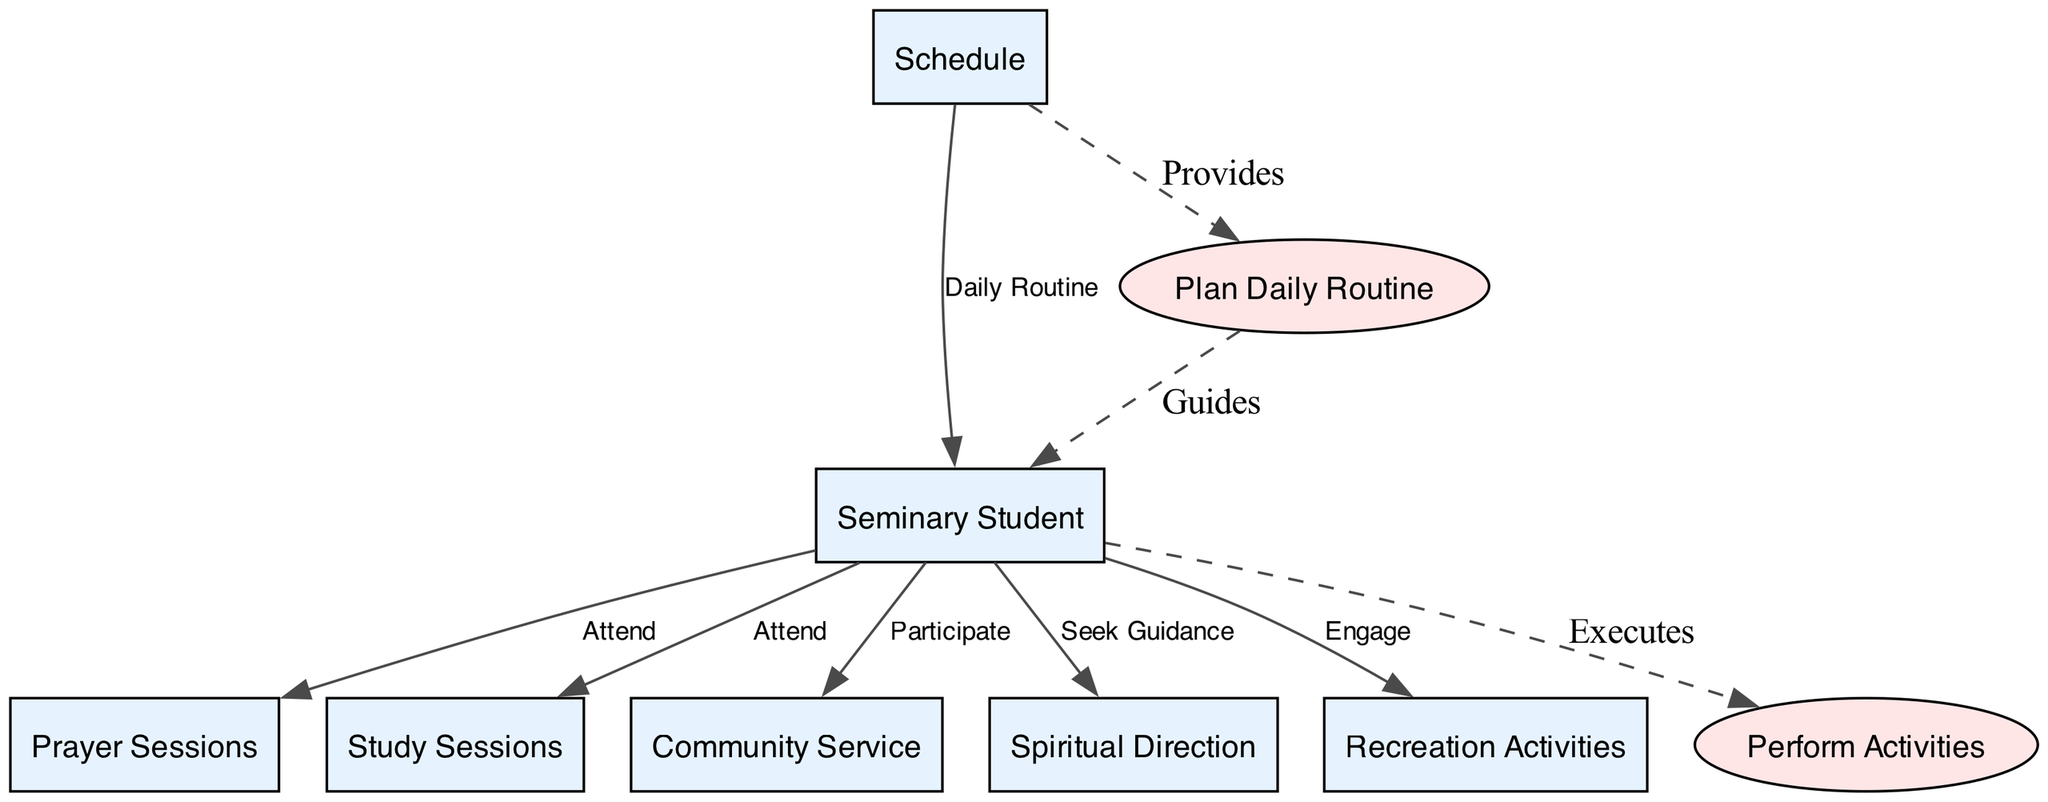What is the main entity represented in the diagram? The main entity in the diagram is the "Seminary Student," which serves as the central focus, interacting with various processes and data flows.
Answer: Seminary Student How many data flows are depicted in the diagram? By counting the arrows representing connections between entities and processes, there are six distinct data flows that illustrate interactions.
Answer: 6 Which process is responsible for guiding the seminary student? The "Plan Daily Routine" process provides guidance to the seminary student, as indicated by the dashed edge connecting it to the student.
Answer: Plan Daily Routine What activity does the seminary student engage in during "Recreation Activities"? The seminary student is expected to "Engage" in Recreation Activities, as illustrated by the data flow connecting the student to this activity.
Answer: Engage What type of activities are included under "Prayer Sessions"? The "Prayer Sessions" include various periods dedicated to prayer, such as Morning Prayer, Mass, and Evening Prayer, which comprise its core activities.
Answer: Morning Prayer, Mass, Evening Prayer How does the schedule influence the daily routine of the seminary student? The "Schedule" influences the daily routine by providing a structured timetable, which directs the seminarian toward various activities throughout the day.
Answer: Provides Which process is executed by the seminary student? The seminary student executes the "Perform Activities" process, which encompasses all scheduled activities from prayer to recreation.
Answer: Perform Activities What is the relationship between the schedule and the "Plan Daily Routine" process? The relationship is that the schedule "Provides" structure to the "Plan Daily Routine" process, which is indicated by a dashed edge flowing from the schedule to the process.
Answer: Provides How many main processes are defined in the diagram? The diagram defines two main processes: "Plan Daily Routine" and "Perform Activities," which are essential components of the seminary student's routine.
Answer: 2 